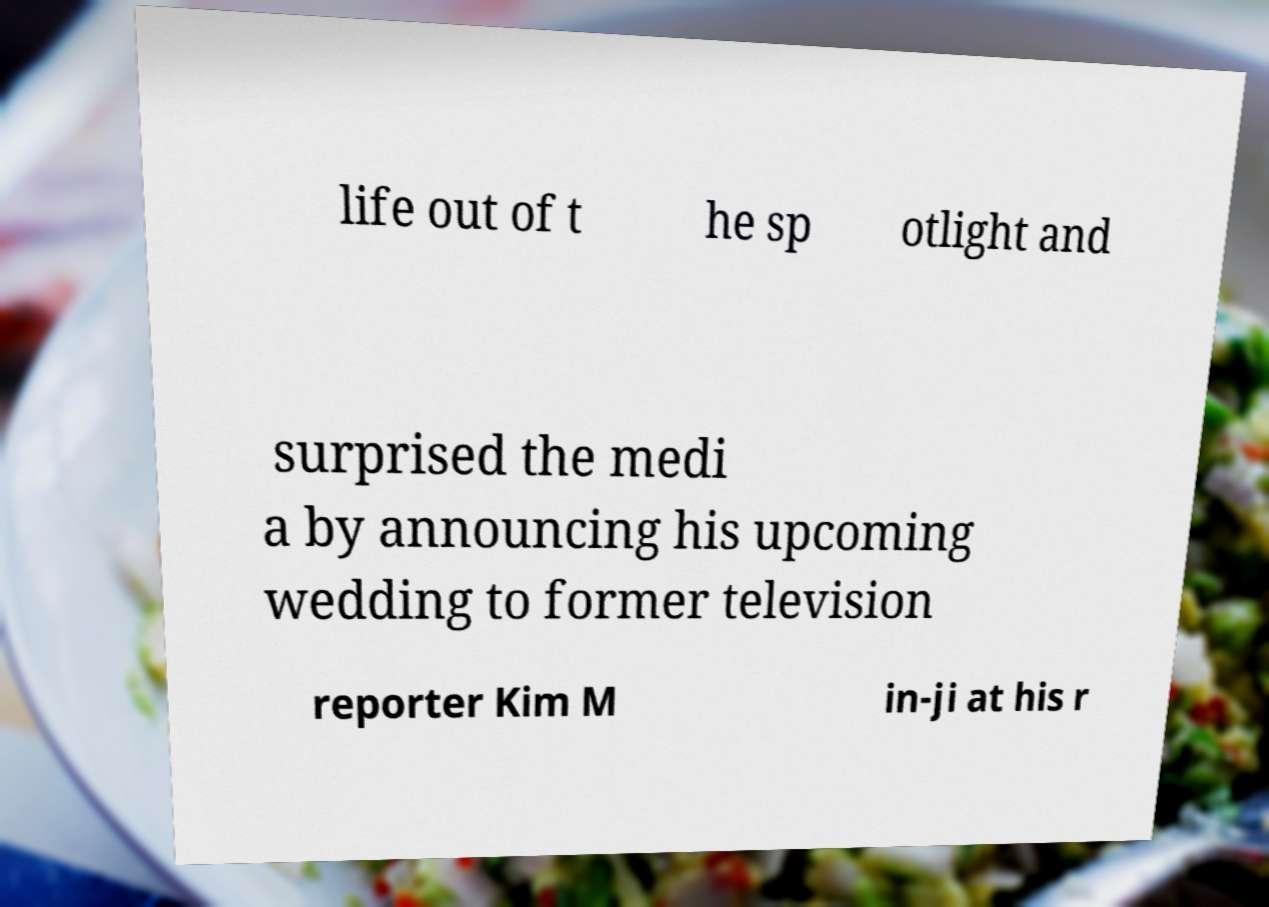Could you extract and type out the text from this image? life out of t he sp otlight and surprised the medi a by announcing his upcoming wedding to former television reporter Kim M in-ji at his r 